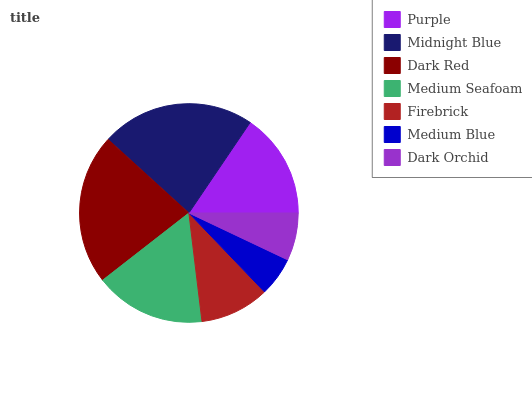Is Medium Blue the minimum?
Answer yes or no. Yes. Is Midnight Blue the maximum?
Answer yes or no. Yes. Is Dark Red the minimum?
Answer yes or no. No. Is Dark Red the maximum?
Answer yes or no. No. Is Midnight Blue greater than Dark Red?
Answer yes or no. Yes. Is Dark Red less than Midnight Blue?
Answer yes or no. Yes. Is Dark Red greater than Midnight Blue?
Answer yes or no. No. Is Midnight Blue less than Dark Red?
Answer yes or no. No. Is Purple the high median?
Answer yes or no. Yes. Is Purple the low median?
Answer yes or no. Yes. Is Firebrick the high median?
Answer yes or no. No. Is Dark Orchid the low median?
Answer yes or no. No. 